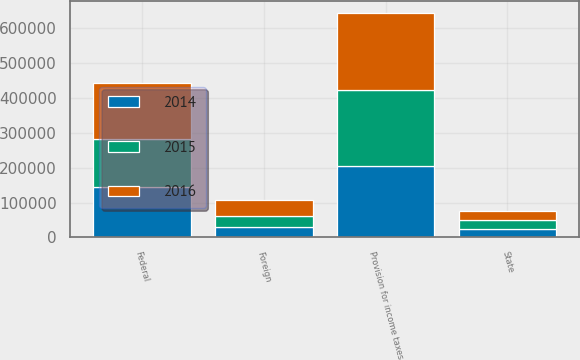<chart> <loc_0><loc_0><loc_500><loc_500><stacked_bar_chart><ecel><fcel>Federal<fcel>State<fcel>Foreign<fcel>Provision for income taxes<nl><fcel>2016<fcel>159547<fcel>27120<fcel>45545<fcel>220566<nl><fcel>2015<fcel>138432<fcel>25952<fcel>32931<fcel>219703<nl><fcel>2014<fcel>144924<fcel>24052<fcel>29046<fcel>204264<nl></chart> 